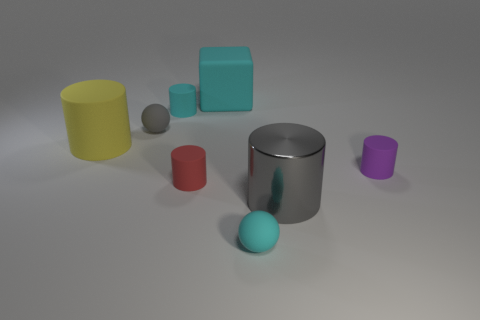Subtract all large metal cylinders. How many cylinders are left? 4 Subtract all yellow cylinders. How many cylinders are left? 4 Subtract all blue cylinders. Subtract all purple balls. How many cylinders are left? 5 Add 2 tiny green rubber balls. How many objects exist? 10 Subtract all cylinders. How many objects are left? 3 Add 2 purple things. How many purple things are left? 3 Add 4 red cylinders. How many red cylinders exist? 5 Subtract 0 blue cubes. How many objects are left? 8 Subtract all cylinders. Subtract all big gray shiny spheres. How many objects are left? 3 